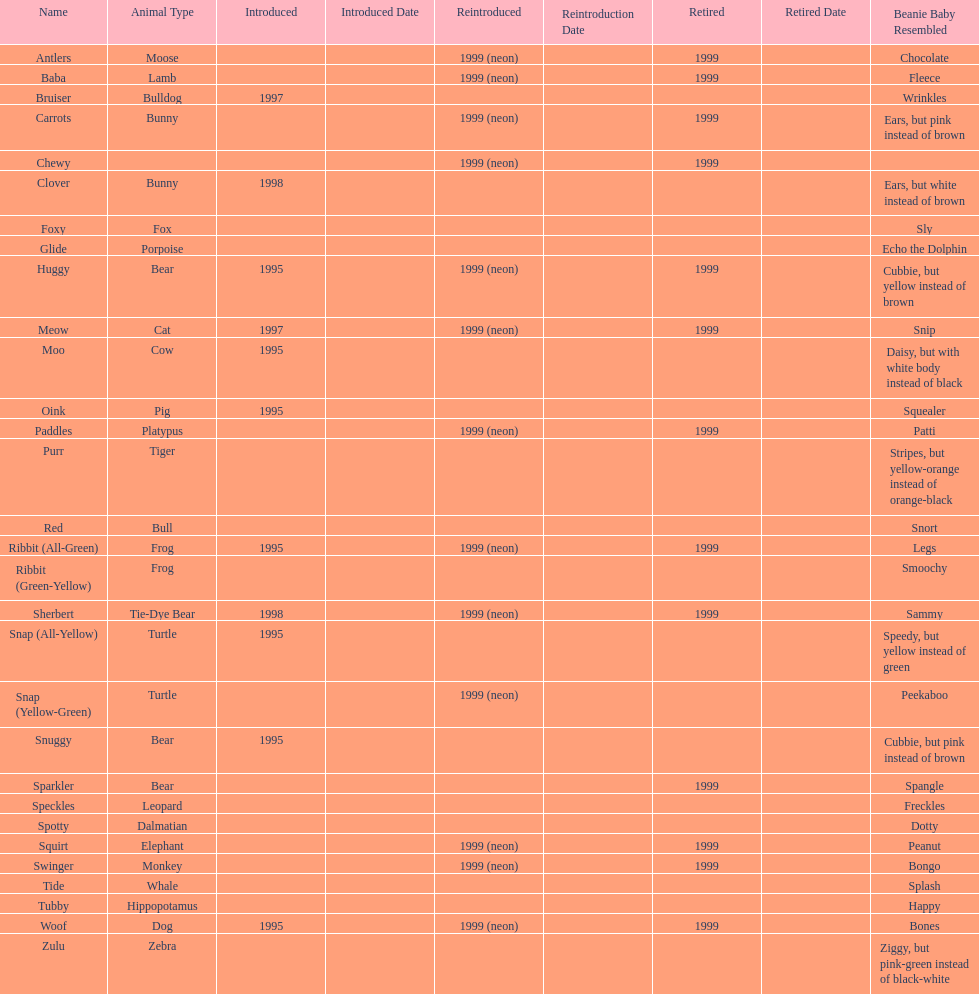How many monkey pillow pals were there? 1. 